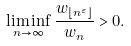<formula> <loc_0><loc_0><loc_500><loc_500>\liminf _ { n \to \infty } \frac { w _ { \lfloor n ^ { \varepsilon } \rfloor } } { w _ { n } } > 0 .</formula> 